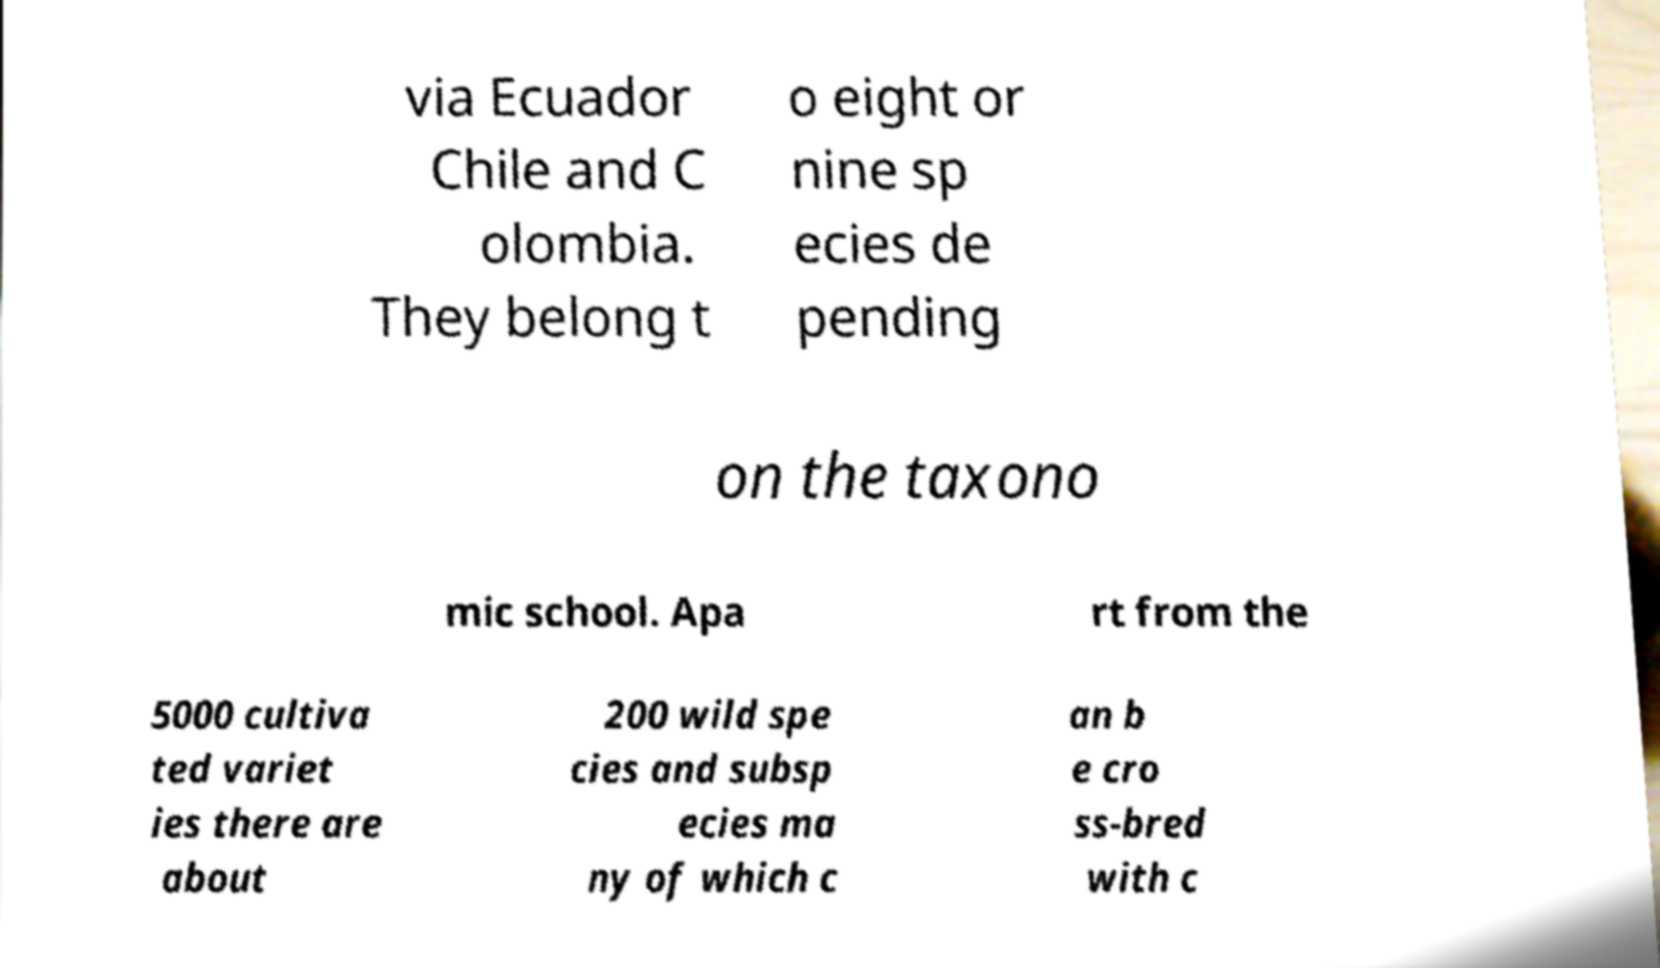What messages or text are displayed in this image? I need them in a readable, typed format. via Ecuador Chile and C olombia. They belong t o eight or nine sp ecies de pending on the taxono mic school. Apa rt from the 5000 cultiva ted variet ies there are about 200 wild spe cies and subsp ecies ma ny of which c an b e cro ss-bred with c 